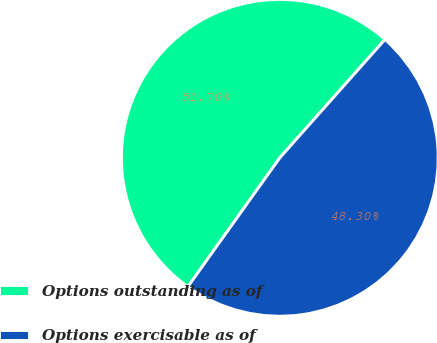Convert chart to OTSL. <chart><loc_0><loc_0><loc_500><loc_500><pie_chart><fcel>Options outstanding as of<fcel>Options exercisable as of<nl><fcel>51.7%<fcel>48.3%<nl></chart> 